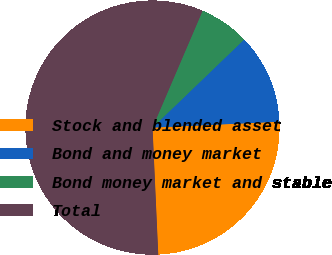Convert chart. <chart><loc_0><loc_0><loc_500><loc_500><pie_chart><fcel>Stock and blended asset<fcel>Bond and money market<fcel>Bond money market and stable<fcel>Total<nl><fcel>25.02%<fcel>11.45%<fcel>6.37%<fcel>57.16%<nl></chart> 